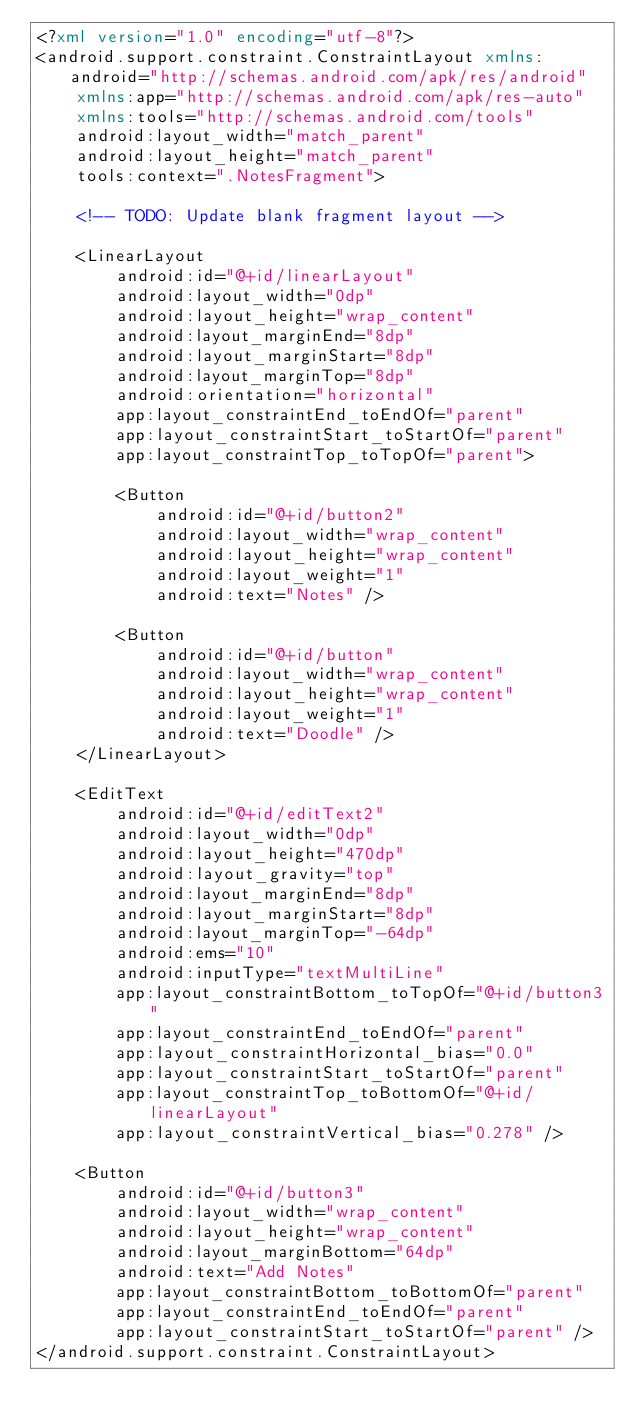Convert code to text. <code><loc_0><loc_0><loc_500><loc_500><_XML_><?xml version="1.0" encoding="utf-8"?>
<android.support.constraint.ConstraintLayout xmlns:android="http://schemas.android.com/apk/res/android"
    xmlns:app="http://schemas.android.com/apk/res-auto"
    xmlns:tools="http://schemas.android.com/tools"
    android:layout_width="match_parent"
    android:layout_height="match_parent"
    tools:context=".NotesFragment">

    <!-- TODO: Update blank fragment layout -->

    <LinearLayout
        android:id="@+id/linearLayout"
        android:layout_width="0dp"
        android:layout_height="wrap_content"
        android:layout_marginEnd="8dp"
        android:layout_marginStart="8dp"
        android:layout_marginTop="8dp"
        android:orientation="horizontal"
        app:layout_constraintEnd_toEndOf="parent"
        app:layout_constraintStart_toStartOf="parent"
        app:layout_constraintTop_toTopOf="parent">

        <Button
            android:id="@+id/button2"
            android:layout_width="wrap_content"
            android:layout_height="wrap_content"
            android:layout_weight="1"
            android:text="Notes" />

        <Button
            android:id="@+id/button"
            android:layout_width="wrap_content"
            android:layout_height="wrap_content"
            android:layout_weight="1"
            android:text="Doodle" />
    </LinearLayout>

    <EditText
        android:id="@+id/editText2"
        android:layout_width="0dp"
        android:layout_height="470dp"
        android:layout_gravity="top"
        android:layout_marginEnd="8dp"
        android:layout_marginStart="8dp"
        android:layout_marginTop="-64dp"
        android:ems="10"
        android:inputType="textMultiLine"
        app:layout_constraintBottom_toTopOf="@+id/button3"
        app:layout_constraintEnd_toEndOf="parent"
        app:layout_constraintHorizontal_bias="0.0"
        app:layout_constraintStart_toStartOf="parent"
        app:layout_constraintTop_toBottomOf="@+id/linearLayout"
        app:layout_constraintVertical_bias="0.278" />

    <Button
        android:id="@+id/button3"
        android:layout_width="wrap_content"
        android:layout_height="wrap_content"
        android:layout_marginBottom="64dp"
        android:text="Add Notes"
        app:layout_constraintBottom_toBottomOf="parent"
        app:layout_constraintEnd_toEndOf="parent"
        app:layout_constraintStart_toStartOf="parent" />
</android.support.constraint.ConstraintLayout></code> 